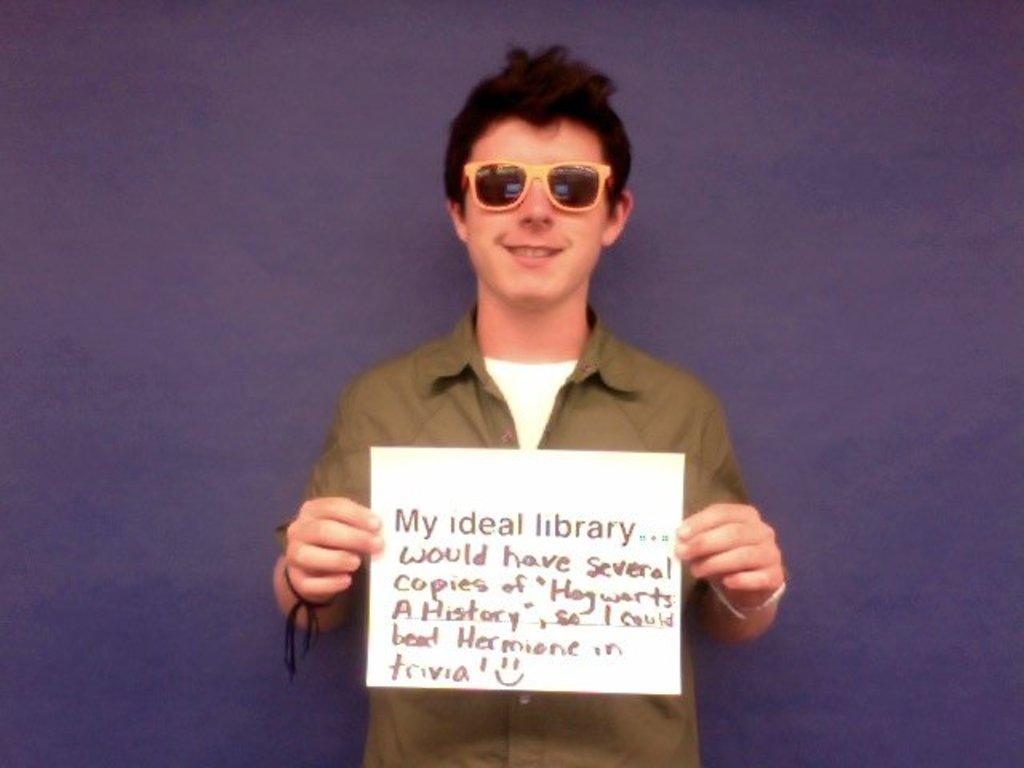What is the main subject of the image? There is a person standing in the center of the image. What is the person holding in the image? The person is holding a paper. Can you describe the paper in more detail? Yes, there is text on the paper. What can be seen in the background of the image? There is a wall in the background of the image. Where are the tomatoes placed on the table in the image? There is no table or tomatoes present in the image. What color is the crayon being used by the person in the image? There is no crayon or indication of drawing in the image. 